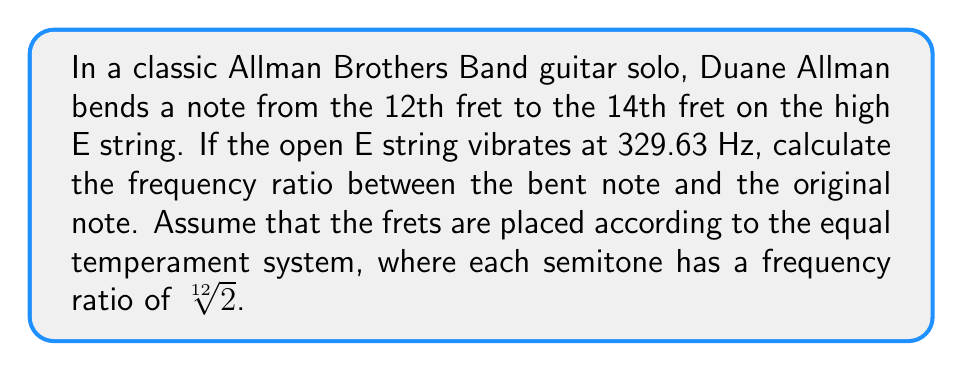What is the answer to this math problem? Let's approach this step-by-step:

1) In the equal temperament system, each fret represents a semitone, and the frequency ratio between adjacent semitones is $\sqrt[12]{2}$.

2) The 12th fret represents an octave above the open string. So the frequency of the 12th fret note is:

   $f_{12} = 329.63 \cdot 2 = 659.26$ Hz

3) The bend from the 12th to the 14th fret represents a whole tone (two semitones). The frequency ratio for two semitones is:

   $(\sqrt[12]{2})^2 = \sqrt[6]{2}$

4) Therefore, the frequency of the bent note (14th fret) is:

   $f_{14} = f_{12} \cdot \sqrt[6]{2} = 659.26 \cdot \sqrt[6]{2}$ Hz

5) The frequency ratio between the bent note and the original note is:

   $$\text{Ratio} = \frac{f_{14}}{f_{12}} = \frac{659.26 \cdot \sqrt[6]{2}}{659.26} = \sqrt[6]{2}$$

6) We can calculate this value:

   $\sqrt[6]{2} \approx 1.1224620483093729814335330496792$
Answer: The frequency ratio between the bent note and the original note is $\sqrt[6]{2}$, or approximately 1.1225. 